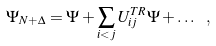Convert formula to latex. <formula><loc_0><loc_0><loc_500><loc_500>\Psi _ { N + \Delta } = \Psi + \sum _ { i < j } U _ { i j } ^ { T R } \Psi + \dots \ ,</formula> 